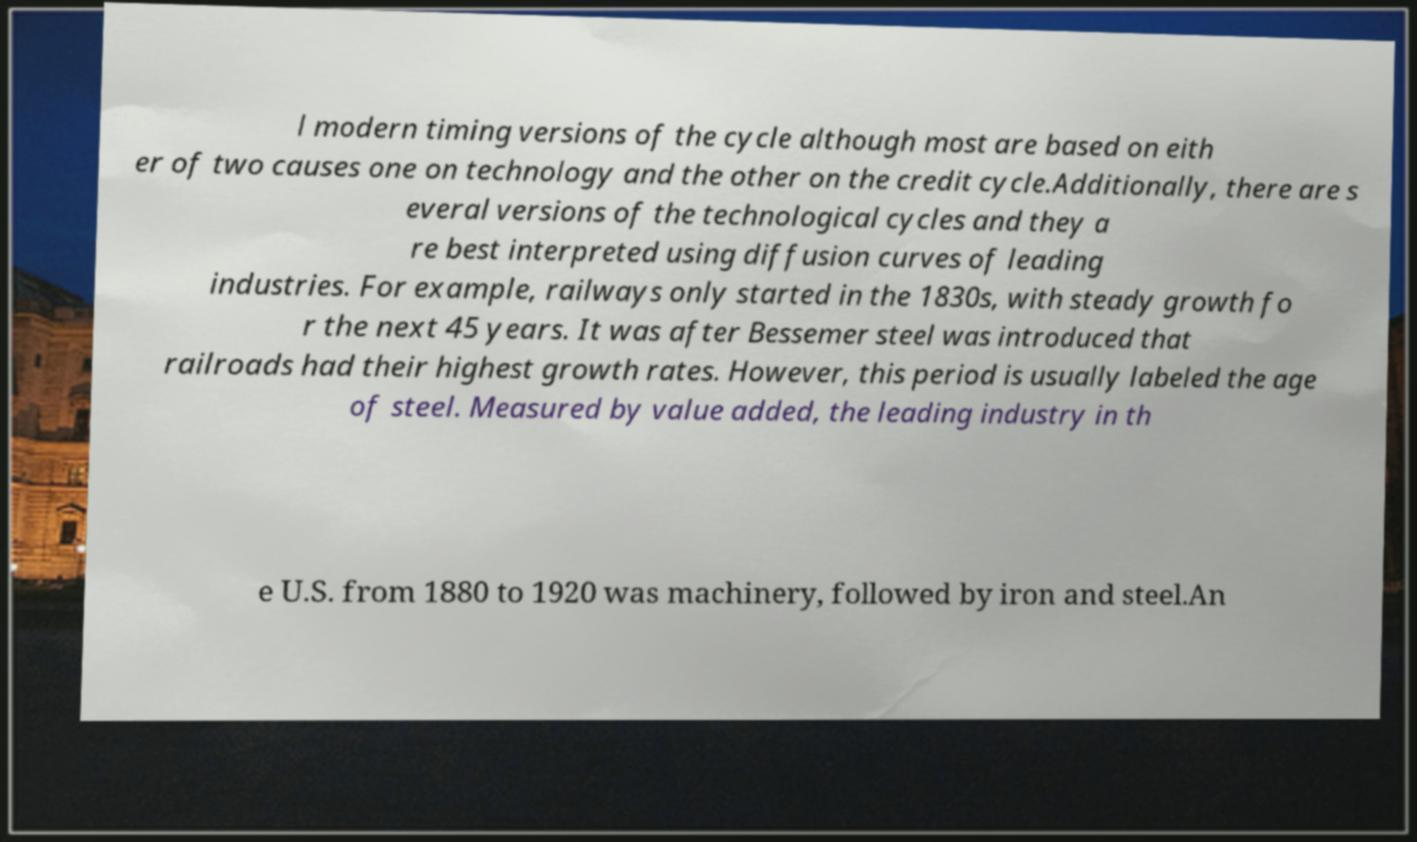Could you assist in decoding the text presented in this image and type it out clearly? l modern timing versions of the cycle although most are based on eith er of two causes one on technology and the other on the credit cycle.Additionally, there are s everal versions of the technological cycles and they a re best interpreted using diffusion curves of leading industries. For example, railways only started in the 1830s, with steady growth fo r the next 45 years. It was after Bessemer steel was introduced that railroads had their highest growth rates. However, this period is usually labeled the age of steel. Measured by value added, the leading industry in th e U.S. from 1880 to 1920 was machinery, followed by iron and steel.An 